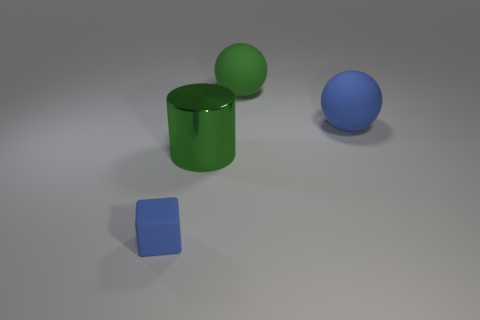The big object that is the same color as the small object is what shape?
Keep it short and to the point. Sphere. The blue sphere is what size?
Offer a very short reply. Large. Is the number of blue things that are to the left of the tiny rubber block greater than the number of objects?
Your answer should be very brief. No. What number of shiny cylinders are behind the tiny blue object?
Your answer should be compact. 1. Is there another green cylinder that has the same size as the green cylinder?
Make the answer very short. No. The other object that is the same shape as the large green matte thing is what color?
Give a very brief answer. Blue. There is a matte ball behind the blue sphere; does it have the same size as the blue rubber thing that is to the right of the blue rubber cube?
Your answer should be compact. Yes. Are there any big blue metallic objects that have the same shape as the green shiny object?
Ensure brevity in your answer.  No. Are there an equal number of small cubes that are in front of the rubber cube and shiny cylinders?
Your answer should be compact. No. There is a blue cube; does it have the same size as the green object that is behind the large green cylinder?
Your answer should be very brief. No. 